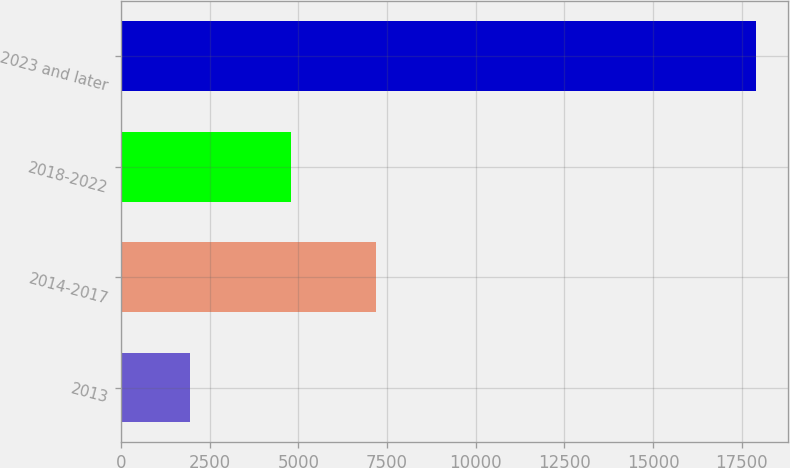<chart> <loc_0><loc_0><loc_500><loc_500><bar_chart><fcel>2013<fcel>2014-2017<fcel>2018-2022<fcel>2023 and later<nl><fcel>1937<fcel>7191<fcel>4803<fcel>17901<nl></chart> 